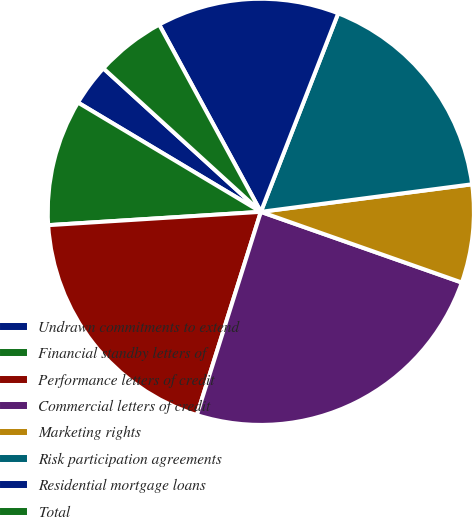Convert chart to OTSL. <chart><loc_0><loc_0><loc_500><loc_500><pie_chart><fcel>Undrawn commitments to extend<fcel>Financial standby letters of<fcel>Performance letters of credit<fcel>Commercial letters of credit<fcel>Marketing rights<fcel>Risk participation agreements<fcel>Residential mortgage loans<fcel>Total<nl><fcel>3.19%<fcel>9.57%<fcel>19.15%<fcel>24.47%<fcel>7.45%<fcel>17.02%<fcel>13.83%<fcel>5.32%<nl></chart> 